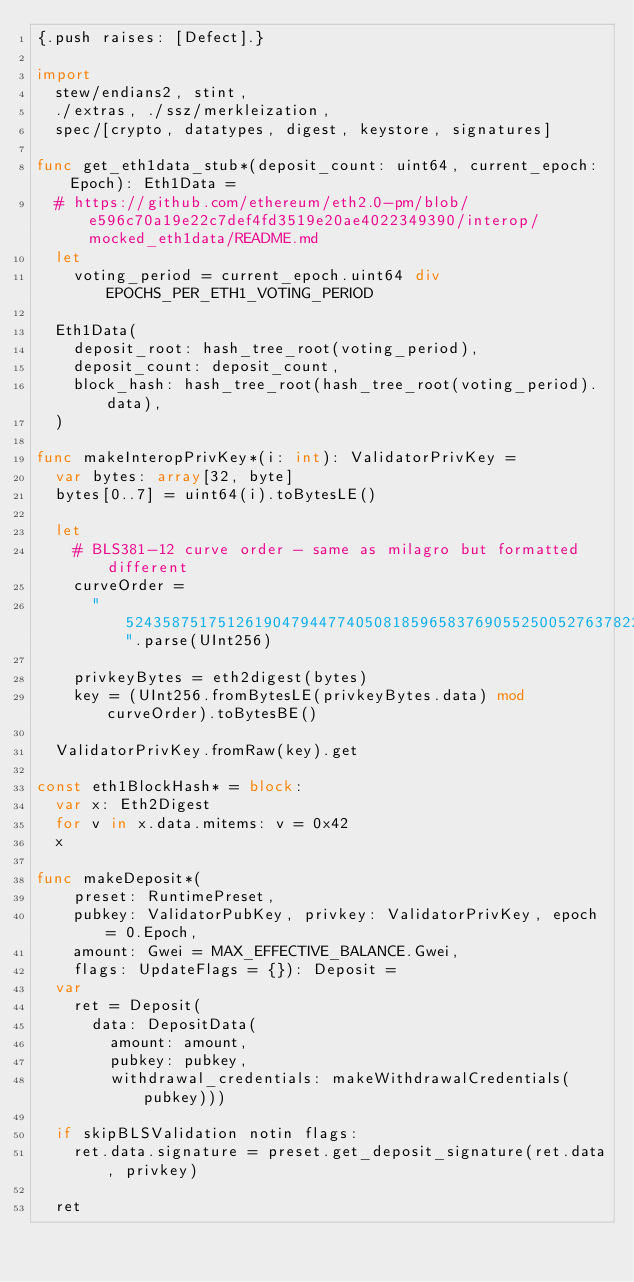<code> <loc_0><loc_0><loc_500><loc_500><_Nim_>{.push raises: [Defect].}

import
  stew/endians2, stint,
  ./extras, ./ssz/merkleization,
  spec/[crypto, datatypes, digest, keystore, signatures]

func get_eth1data_stub*(deposit_count: uint64, current_epoch: Epoch): Eth1Data =
  # https://github.com/ethereum/eth2.0-pm/blob/e596c70a19e22c7def4fd3519e20ae4022349390/interop/mocked_eth1data/README.md
  let
    voting_period = current_epoch.uint64 div EPOCHS_PER_ETH1_VOTING_PERIOD

  Eth1Data(
    deposit_root: hash_tree_root(voting_period),
    deposit_count: deposit_count,
    block_hash: hash_tree_root(hash_tree_root(voting_period).data),
  )

func makeInteropPrivKey*(i: int): ValidatorPrivKey =
  var bytes: array[32, byte]
  bytes[0..7] = uint64(i).toBytesLE()

  let
    # BLS381-12 curve order - same as milagro but formatted different
    curveOrder =
      "52435875175126190479447740508185965837690552500527637822603658699938581184513".parse(UInt256)

    privkeyBytes = eth2digest(bytes)
    key = (UInt256.fromBytesLE(privkeyBytes.data) mod curveOrder).toBytesBE()

  ValidatorPrivKey.fromRaw(key).get

const eth1BlockHash* = block:
  var x: Eth2Digest
  for v in x.data.mitems: v = 0x42
  x

func makeDeposit*(
    preset: RuntimePreset,
    pubkey: ValidatorPubKey, privkey: ValidatorPrivKey, epoch = 0.Epoch,
    amount: Gwei = MAX_EFFECTIVE_BALANCE.Gwei,
    flags: UpdateFlags = {}): Deposit =
  var
    ret = Deposit(
      data: DepositData(
        amount: amount,
        pubkey: pubkey,
        withdrawal_credentials: makeWithdrawalCredentials(pubkey)))

  if skipBLSValidation notin flags:
    ret.data.signature = preset.get_deposit_signature(ret.data, privkey)

  ret
</code> 